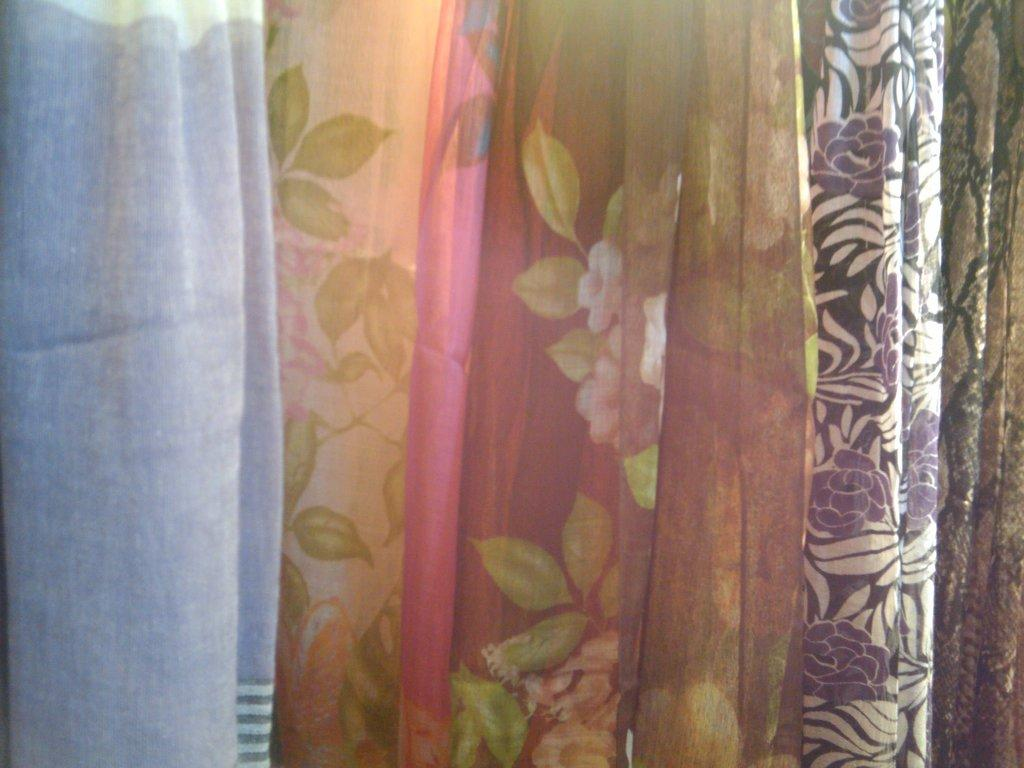What can be seen in the image related to clothing? There are different types of clothes in the image. How are the clothes arranged in the image? The clothes are hanged down. What type of whip is being used to hang the clothes in the image? There is no whip present in the image; the clothes are simply hanging down. How many dimes can be seen on the clothes in the image? There are no dimes visible on the clothes in the image. 